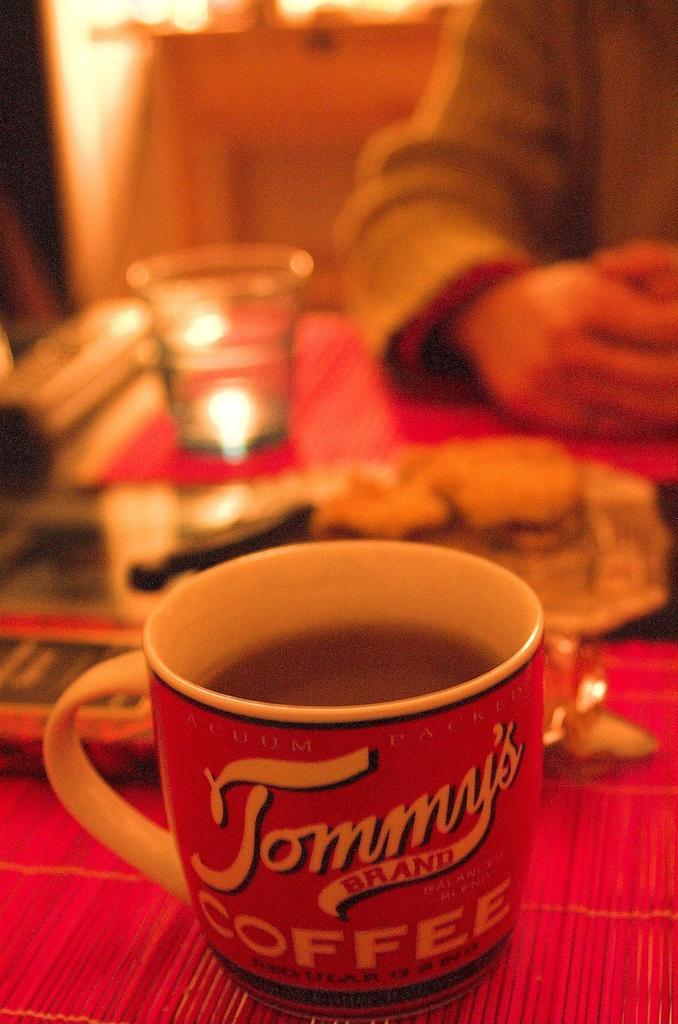Please provide a concise description of this image. In this image we can see a cup with liquid, glass, and objects on a platform. Here we can see hand of a person. There is a blur background. 